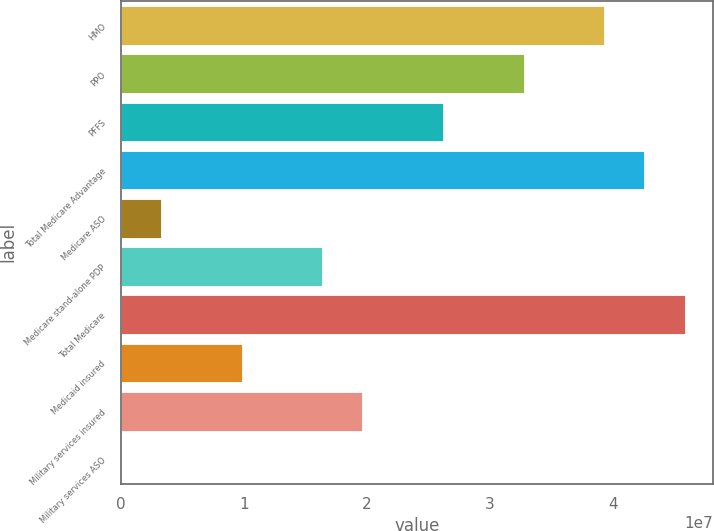<chart> <loc_0><loc_0><loc_500><loc_500><bar_chart><fcel>HMO<fcel>PPO<fcel>PFFS<fcel>Total Medicare Advantage<fcel>Medicare ASO<fcel>Medicare stand-alone PDP<fcel>Total Medicare<fcel>Medicaid insured<fcel>Military services insured<fcel>Military services ASO<nl><fcel>3.92548e+07<fcel>3.27123e+07<fcel>2.61699e+07<fcel>4.2526e+07<fcel>3.27123e+06<fcel>1.63562e+07<fcel>4.57973e+07<fcel>9.8137e+06<fcel>1.96274e+07<fcel>0.58<nl></chart> 